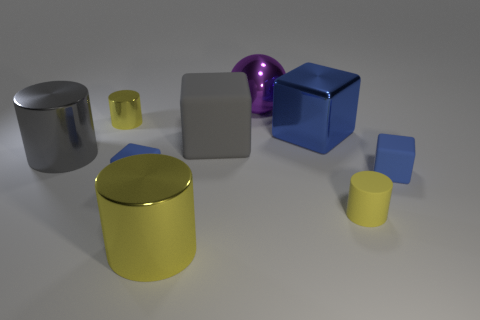Subtract all yellow cylinders. How many were subtracted if there are1yellow cylinders left? 2 Subtract all matte cubes. How many cubes are left? 1 Add 1 tiny blue balls. How many objects exist? 10 Subtract 1 cylinders. How many cylinders are left? 3 Subtract all balls. How many objects are left? 8 Subtract all gray cylinders. How many cylinders are left? 3 Subtract all gray blocks. How many yellow cylinders are left? 3 Add 2 large gray cylinders. How many large gray cylinders are left? 3 Add 3 tiny matte objects. How many tiny matte objects exist? 6 Subtract 0 red blocks. How many objects are left? 9 